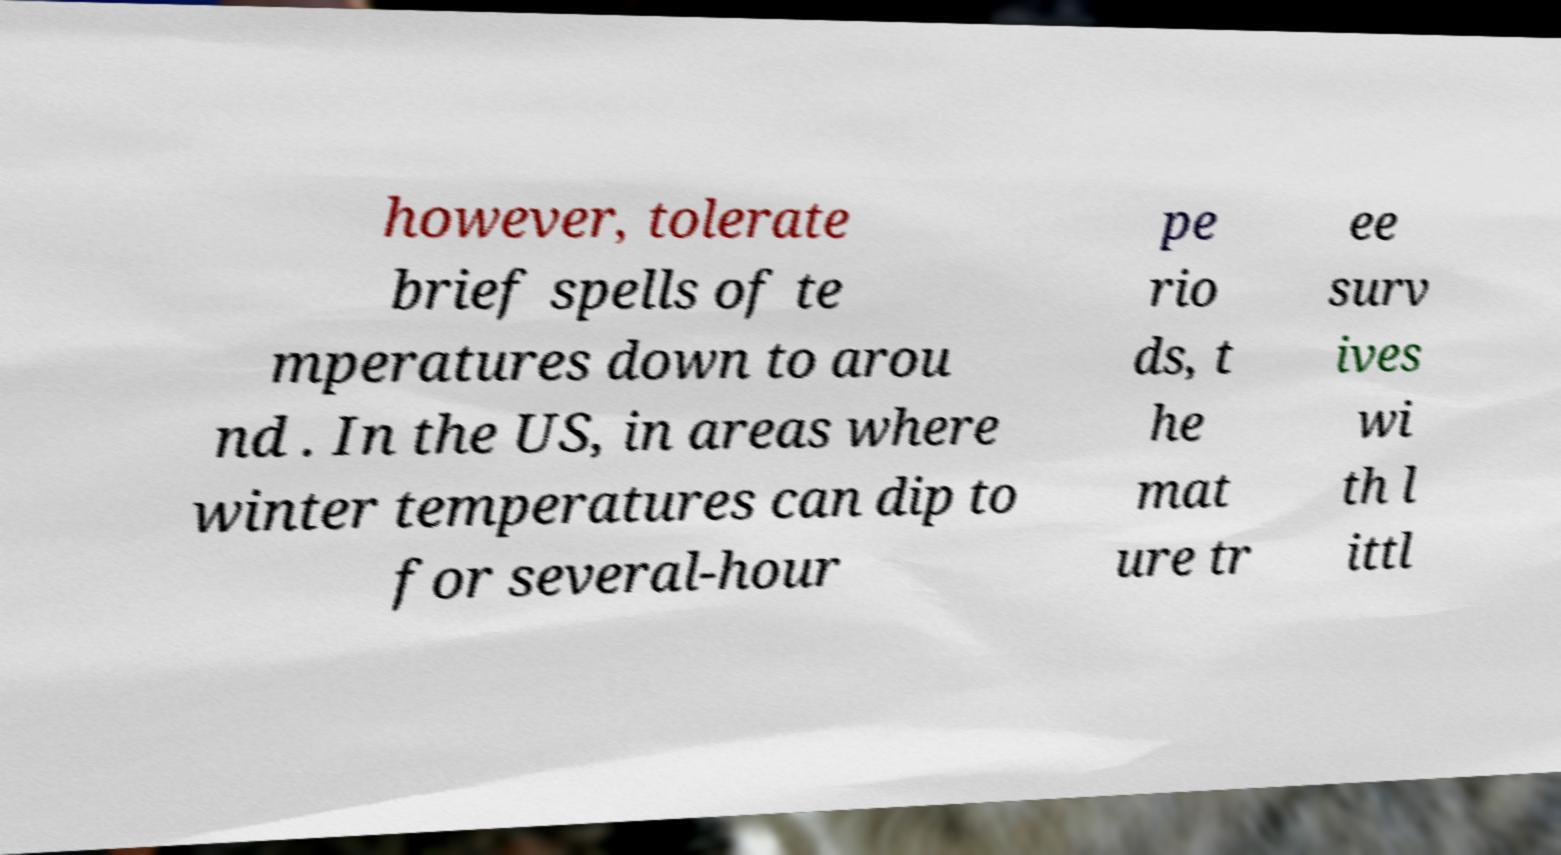Can you accurately transcribe the text from the provided image for me? however, tolerate brief spells of te mperatures down to arou nd . In the US, in areas where winter temperatures can dip to for several-hour pe rio ds, t he mat ure tr ee surv ives wi th l ittl 